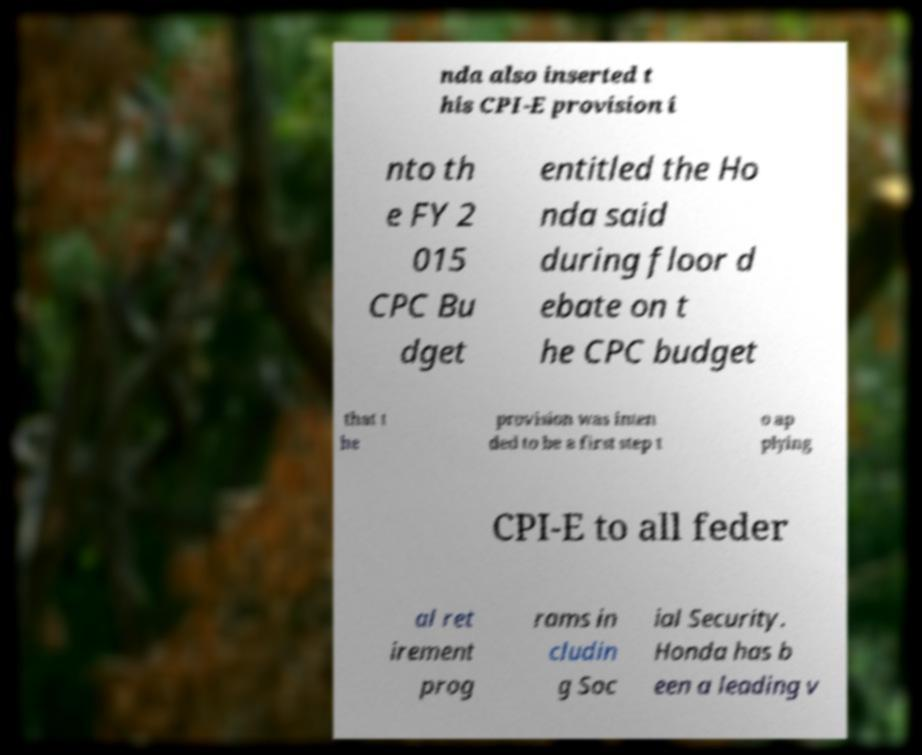Can you read and provide the text displayed in the image?This photo seems to have some interesting text. Can you extract and type it out for me? nda also inserted t his CPI-E provision i nto th e FY 2 015 CPC Bu dget entitled the Ho nda said during floor d ebate on t he CPC budget that t he provision was inten ded to be a first step t o ap plying CPI-E to all feder al ret irement prog rams in cludin g Soc ial Security. Honda has b een a leading v 